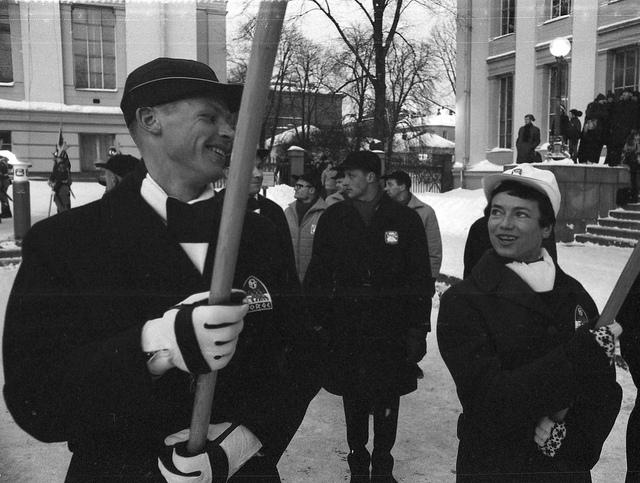Do the people carrying the flag poles enjoy each others company?
Short answer required. Yes. What color are the men's gloves?
Give a very brief answer. White. Are they in a parade?
Quick response, please. Yes. 